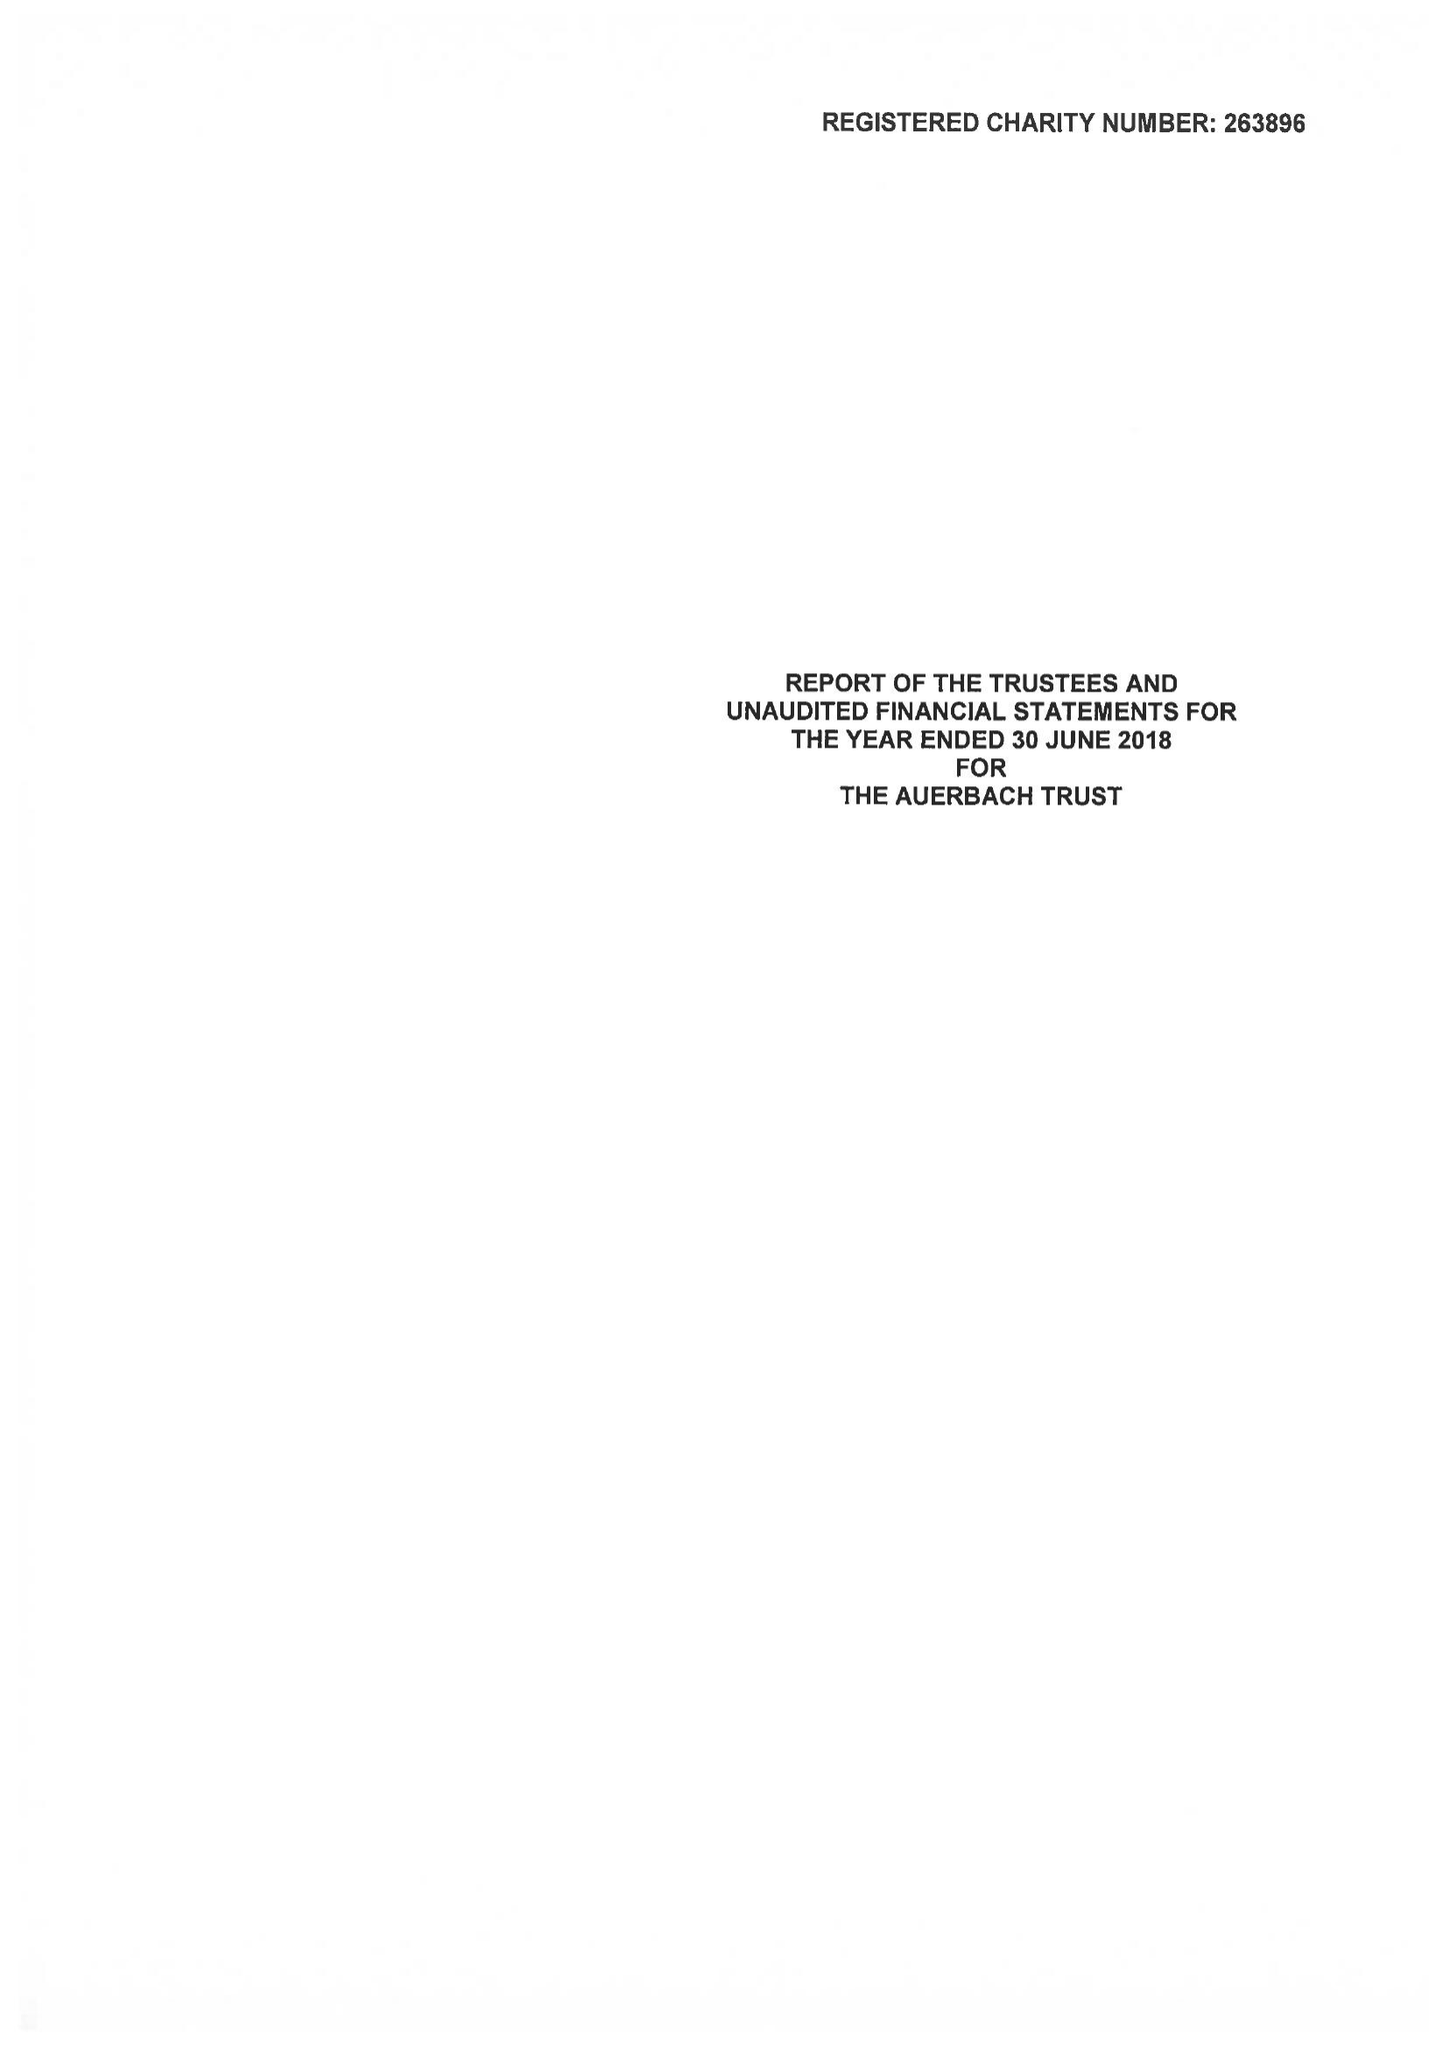What is the value for the address__street_line?
Answer the question using a single word or phrase. 21 CLARENCE TERRACE 